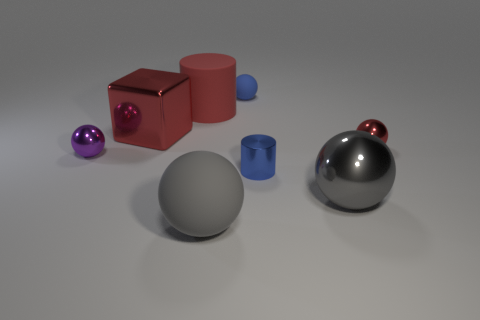Is the color of the big rubber ball the same as the big metallic ball?
Make the answer very short. Yes. What is the material of the ball that is the same color as the large matte cylinder?
Provide a short and direct response. Metal. What number of big things have the same color as the large cylinder?
Give a very brief answer. 1. Do the blue rubber ball and the red shiny ball have the same size?
Give a very brief answer. Yes. What is the size of the red object right of the blue sphere behind the large shiny sphere?
Your answer should be very brief. Small. There is a big metal sphere; does it have the same color as the matte thing in front of the purple sphere?
Provide a short and direct response. Yes. Are there any blue shiny objects that have the same size as the blue matte sphere?
Your response must be concise. Yes. There is a red thing that is on the right side of the tiny cylinder; what size is it?
Provide a succinct answer. Small. Is there a tiny thing on the right side of the red metallic object that is behind the tiny red metal object?
Provide a short and direct response. Yes. How many other things are the same shape as the purple object?
Your response must be concise. 4. 